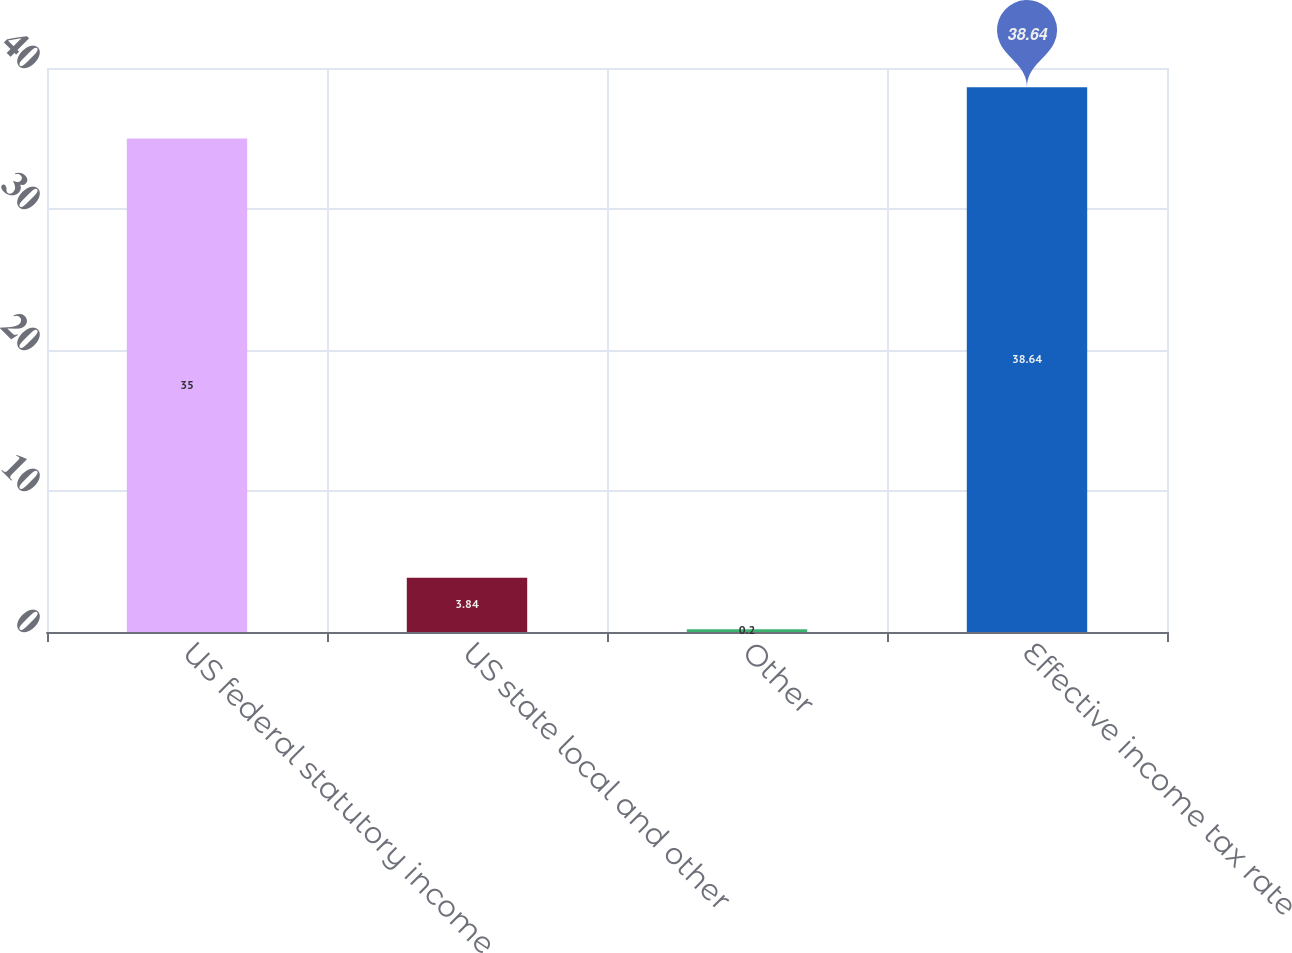Convert chart. <chart><loc_0><loc_0><loc_500><loc_500><bar_chart><fcel>US federal statutory income<fcel>US state local and other<fcel>Other<fcel>Effective income tax rate<nl><fcel>35<fcel>3.84<fcel>0.2<fcel>38.64<nl></chart> 